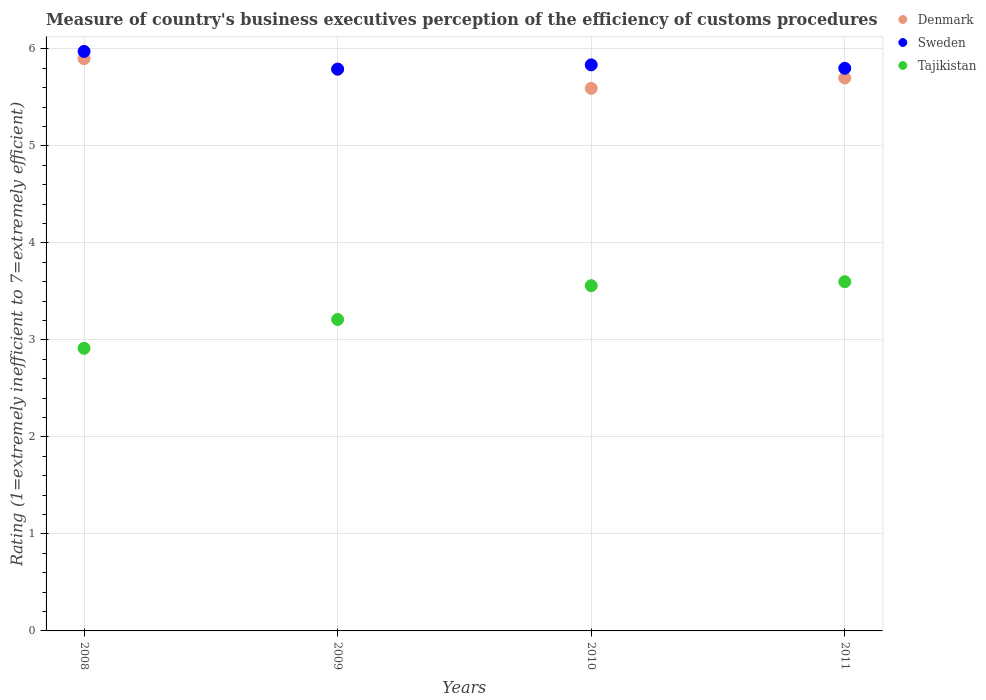Is the number of dotlines equal to the number of legend labels?
Offer a very short reply. Yes. What is the rating of the efficiency of customs procedure in Denmark in 2010?
Your answer should be compact. 5.59. Across all years, what is the maximum rating of the efficiency of customs procedure in Sweden?
Provide a short and direct response. 5.97. Across all years, what is the minimum rating of the efficiency of customs procedure in Denmark?
Keep it short and to the point. 5.59. What is the total rating of the efficiency of customs procedure in Denmark in the graph?
Make the answer very short. 22.98. What is the difference between the rating of the efficiency of customs procedure in Sweden in 2009 and that in 2011?
Make the answer very short. -0.01. What is the difference between the rating of the efficiency of customs procedure in Denmark in 2011 and the rating of the efficiency of customs procedure in Sweden in 2009?
Ensure brevity in your answer.  -0.09. What is the average rating of the efficiency of customs procedure in Denmark per year?
Your answer should be very brief. 5.75. In the year 2008, what is the difference between the rating of the efficiency of customs procedure in Tajikistan and rating of the efficiency of customs procedure in Sweden?
Your answer should be very brief. -3.06. In how many years, is the rating of the efficiency of customs procedure in Sweden greater than 4?
Give a very brief answer. 4. What is the ratio of the rating of the efficiency of customs procedure in Sweden in 2008 to that in 2011?
Offer a terse response. 1.03. Is the difference between the rating of the efficiency of customs procedure in Tajikistan in 2008 and 2009 greater than the difference between the rating of the efficiency of customs procedure in Sweden in 2008 and 2009?
Offer a very short reply. No. What is the difference between the highest and the second highest rating of the efficiency of customs procedure in Denmark?
Provide a succinct answer. 0.11. What is the difference between the highest and the lowest rating of the efficiency of customs procedure in Tajikistan?
Provide a short and direct response. 0.69. In how many years, is the rating of the efficiency of customs procedure in Sweden greater than the average rating of the efficiency of customs procedure in Sweden taken over all years?
Your response must be concise. 1. Is the sum of the rating of the efficiency of customs procedure in Sweden in 2008 and 2011 greater than the maximum rating of the efficiency of customs procedure in Tajikistan across all years?
Your answer should be compact. Yes. Is the rating of the efficiency of customs procedure in Tajikistan strictly less than the rating of the efficiency of customs procedure in Sweden over the years?
Give a very brief answer. Yes. How many dotlines are there?
Provide a short and direct response. 3. How many years are there in the graph?
Provide a short and direct response. 4. What is the difference between two consecutive major ticks on the Y-axis?
Ensure brevity in your answer.  1. Where does the legend appear in the graph?
Keep it short and to the point. Top right. What is the title of the graph?
Offer a very short reply. Measure of country's business executives perception of the efficiency of customs procedures. What is the label or title of the X-axis?
Your answer should be compact. Years. What is the label or title of the Y-axis?
Provide a short and direct response. Rating (1=extremely inefficient to 7=extremely efficient). What is the Rating (1=extremely inefficient to 7=extremely efficient) of Denmark in 2008?
Provide a short and direct response. 5.9. What is the Rating (1=extremely inefficient to 7=extremely efficient) in Sweden in 2008?
Your answer should be very brief. 5.97. What is the Rating (1=extremely inefficient to 7=extremely efficient) in Tajikistan in 2008?
Your answer should be compact. 2.91. What is the Rating (1=extremely inefficient to 7=extremely efficient) of Denmark in 2009?
Ensure brevity in your answer.  5.79. What is the Rating (1=extremely inefficient to 7=extremely efficient) in Sweden in 2009?
Provide a short and direct response. 5.79. What is the Rating (1=extremely inefficient to 7=extremely efficient) of Tajikistan in 2009?
Ensure brevity in your answer.  3.21. What is the Rating (1=extremely inefficient to 7=extremely efficient) in Denmark in 2010?
Your answer should be very brief. 5.59. What is the Rating (1=extremely inefficient to 7=extremely efficient) in Sweden in 2010?
Keep it short and to the point. 5.84. What is the Rating (1=extremely inefficient to 7=extremely efficient) in Tajikistan in 2010?
Keep it short and to the point. 3.56. What is the Rating (1=extremely inefficient to 7=extremely efficient) in Denmark in 2011?
Offer a terse response. 5.7. What is the Rating (1=extremely inefficient to 7=extremely efficient) of Sweden in 2011?
Your response must be concise. 5.8. Across all years, what is the maximum Rating (1=extremely inefficient to 7=extremely efficient) of Denmark?
Ensure brevity in your answer.  5.9. Across all years, what is the maximum Rating (1=extremely inefficient to 7=extremely efficient) of Sweden?
Your answer should be very brief. 5.97. Across all years, what is the maximum Rating (1=extremely inefficient to 7=extremely efficient) of Tajikistan?
Make the answer very short. 3.6. Across all years, what is the minimum Rating (1=extremely inefficient to 7=extremely efficient) in Denmark?
Ensure brevity in your answer.  5.59. Across all years, what is the minimum Rating (1=extremely inefficient to 7=extremely efficient) in Sweden?
Offer a terse response. 5.79. Across all years, what is the minimum Rating (1=extremely inefficient to 7=extremely efficient) of Tajikistan?
Offer a very short reply. 2.91. What is the total Rating (1=extremely inefficient to 7=extremely efficient) in Denmark in the graph?
Ensure brevity in your answer.  22.98. What is the total Rating (1=extremely inefficient to 7=extremely efficient) of Sweden in the graph?
Keep it short and to the point. 23.4. What is the total Rating (1=extremely inefficient to 7=extremely efficient) in Tajikistan in the graph?
Keep it short and to the point. 13.28. What is the difference between the Rating (1=extremely inefficient to 7=extremely efficient) of Denmark in 2008 and that in 2009?
Your answer should be very brief. 0.11. What is the difference between the Rating (1=extremely inefficient to 7=extremely efficient) in Sweden in 2008 and that in 2009?
Your answer should be compact. 0.18. What is the difference between the Rating (1=extremely inefficient to 7=extremely efficient) of Tajikistan in 2008 and that in 2009?
Make the answer very short. -0.3. What is the difference between the Rating (1=extremely inefficient to 7=extremely efficient) in Denmark in 2008 and that in 2010?
Keep it short and to the point. 0.31. What is the difference between the Rating (1=extremely inefficient to 7=extremely efficient) of Sweden in 2008 and that in 2010?
Give a very brief answer. 0.14. What is the difference between the Rating (1=extremely inefficient to 7=extremely efficient) of Tajikistan in 2008 and that in 2010?
Offer a terse response. -0.65. What is the difference between the Rating (1=extremely inefficient to 7=extremely efficient) of Denmark in 2008 and that in 2011?
Your response must be concise. 0.2. What is the difference between the Rating (1=extremely inefficient to 7=extremely efficient) of Sweden in 2008 and that in 2011?
Provide a short and direct response. 0.17. What is the difference between the Rating (1=extremely inefficient to 7=extremely efficient) of Tajikistan in 2008 and that in 2011?
Ensure brevity in your answer.  -0.69. What is the difference between the Rating (1=extremely inefficient to 7=extremely efficient) of Denmark in 2009 and that in 2010?
Keep it short and to the point. 0.2. What is the difference between the Rating (1=extremely inefficient to 7=extremely efficient) of Sweden in 2009 and that in 2010?
Your response must be concise. -0.04. What is the difference between the Rating (1=extremely inefficient to 7=extremely efficient) of Tajikistan in 2009 and that in 2010?
Give a very brief answer. -0.35. What is the difference between the Rating (1=extremely inefficient to 7=extremely efficient) in Denmark in 2009 and that in 2011?
Your answer should be very brief. 0.09. What is the difference between the Rating (1=extremely inefficient to 7=extremely efficient) of Sweden in 2009 and that in 2011?
Your answer should be compact. -0.01. What is the difference between the Rating (1=extremely inefficient to 7=extremely efficient) of Tajikistan in 2009 and that in 2011?
Your answer should be compact. -0.39. What is the difference between the Rating (1=extremely inefficient to 7=extremely efficient) in Denmark in 2010 and that in 2011?
Provide a short and direct response. -0.11. What is the difference between the Rating (1=extremely inefficient to 7=extremely efficient) in Sweden in 2010 and that in 2011?
Keep it short and to the point. 0.04. What is the difference between the Rating (1=extremely inefficient to 7=extremely efficient) in Tajikistan in 2010 and that in 2011?
Keep it short and to the point. -0.04. What is the difference between the Rating (1=extremely inefficient to 7=extremely efficient) in Denmark in 2008 and the Rating (1=extremely inefficient to 7=extremely efficient) in Sweden in 2009?
Your answer should be very brief. 0.11. What is the difference between the Rating (1=extremely inefficient to 7=extremely efficient) of Denmark in 2008 and the Rating (1=extremely inefficient to 7=extremely efficient) of Tajikistan in 2009?
Provide a short and direct response. 2.69. What is the difference between the Rating (1=extremely inefficient to 7=extremely efficient) of Sweden in 2008 and the Rating (1=extremely inefficient to 7=extremely efficient) of Tajikistan in 2009?
Offer a very short reply. 2.76. What is the difference between the Rating (1=extremely inefficient to 7=extremely efficient) of Denmark in 2008 and the Rating (1=extremely inefficient to 7=extremely efficient) of Sweden in 2010?
Give a very brief answer. 0.06. What is the difference between the Rating (1=extremely inefficient to 7=extremely efficient) in Denmark in 2008 and the Rating (1=extremely inefficient to 7=extremely efficient) in Tajikistan in 2010?
Offer a very short reply. 2.34. What is the difference between the Rating (1=extremely inefficient to 7=extremely efficient) of Sweden in 2008 and the Rating (1=extremely inefficient to 7=extremely efficient) of Tajikistan in 2010?
Your answer should be very brief. 2.41. What is the difference between the Rating (1=extremely inefficient to 7=extremely efficient) of Denmark in 2008 and the Rating (1=extremely inefficient to 7=extremely efficient) of Sweden in 2011?
Keep it short and to the point. 0.1. What is the difference between the Rating (1=extremely inefficient to 7=extremely efficient) of Denmark in 2008 and the Rating (1=extremely inefficient to 7=extremely efficient) of Tajikistan in 2011?
Your answer should be compact. 2.3. What is the difference between the Rating (1=extremely inefficient to 7=extremely efficient) in Sweden in 2008 and the Rating (1=extremely inefficient to 7=extremely efficient) in Tajikistan in 2011?
Offer a terse response. 2.37. What is the difference between the Rating (1=extremely inefficient to 7=extremely efficient) of Denmark in 2009 and the Rating (1=extremely inefficient to 7=extremely efficient) of Sweden in 2010?
Your answer should be compact. -0.05. What is the difference between the Rating (1=extremely inefficient to 7=extremely efficient) in Denmark in 2009 and the Rating (1=extremely inefficient to 7=extremely efficient) in Tajikistan in 2010?
Ensure brevity in your answer.  2.23. What is the difference between the Rating (1=extremely inefficient to 7=extremely efficient) in Sweden in 2009 and the Rating (1=extremely inefficient to 7=extremely efficient) in Tajikistan in 2010?
Offer a very short reply. 2.23. What is the difference between the Rating (1=extremely inefficient to 7=extremely efficient) of Denmark in 2009 and the Rating (1=extremely inefficient to 7=extremely efficient) of Sweden in 2011?
Keep it short and to the point. -0.01. What is the difference between the Rating (1=extremely inefficient to 7=extremely efficient) of Denmark in 2009 and the Rating (1=extremely inefficient to 7=extremely efficient) of Tajikistan in 2011?
Ensure brevity in your answer.  2.19. What is the difference between the Rating (1=extremely inefficient to 7=extremely efficient) of Sweden in 2009 and the Rating (1=extremely inefficient to 7=extremely efficient) of Tajikistan in 2011?
Your response must be concise. 2.19. What is the difference between the Rating (1=extremely inefficient to 7=extremely efficient) in Denmark in 2010 and the Rating (1=extremely inefficient to 7=extremely efficient) in Sweden in 2011?
Ensure brevity in your answer.  -0.21. What is the difference between the Rating (1=extremely inefficient to 7=extremely efficient) in Denmark in 2010 and the Rating (1=extremely inefficient to 7=extremely efficient) in Tajikistan in 2011?
Provide a short and direct response. 1.99. What is the difference between the Rating (1=extremely inefficient to 7=extremely efficient) in Sweden in 2010 and the Rating (1=extremely inefficient to 7=extremely efficient) in Tajikistan in 2011?
Offer a very short reply. 2.24. What is the average Rating (1=extremely inefficient to 7=extremely efficient) of Denmark per year?
Provide a succinct answer. 5.75. What is the average Rating (1=extremely inefficient to 7=extremely efficient) of Sweden per year?
Give a very brief answer. 5.85. What is the average Rating (1=extremely inefficient to 7=extremely efficient) in Tajikistan per year?
Your response must be concise. 3.32. In the year 2008, what is the difference between the Rating (1=extremely inefficient to 7=extremely efficient) in Denmark and Rating (1=extremely inefficient to 7=extremely efficient) in Sweden?
Keep it short and to the point. -0.07. In the year 2008, what is the difference between the Rating (1=extremely inefficient to 7=extremely efficient) in Denmark and Rating (1=extremely inefficient to 7=extremely efficient) in Tajikistan?
Offer a very short reply. 2.99. In the year 2008, what is the difference between the Rating (1=extremely inefficient to 7=extremely efficient) in Sweden and Rating (1=extremely inefficient to 7=extremely efficient) in Tajikistan?
Offer a terse response. 3.06. In the year 2009, what is the difference between the Rating (1=extremely inefficient to 7=extremely efficient) of Denmark and Rating (1=extremely inefficient to 7=extremely efficient) of Sweden?
Offer a terse response. -0. In the year 2009, what is the difference between the Rating (1=extremely inefficient to 7=extremely efficient) of Denmark and Rating (1=extremely inefficient to 7=extremely efficient) of Tajikistan?
Your answer should be very brief. 2.58. In the year 2009, what is the difference between the Rating (1=extremely inefficient to 7=extremely efficient) in Sweden and Rating (1=extremely inefficient to 7=extremely efficient) in Tajikistan?
Provide a short and direct response. 2.58. In the year 2010, what is the difference between the Rating (1=extremely inefficient to 7=extremely efficient) of Denmark and Rating (1=extremely inefficient to 7=extremely efficient) of Sweden?
Make the answer very short. -0.24. In the year 2010, what is the difference between the Rating (1=extremely inefficient to 7=extremely efficient) in Denmark and Rating (1=extremely inefficient to 7=extremely efficient) in Tajikistan?
Your response must be concise. 2.03. In the year 2010, what is the difference between the Rating (1=extremely inefficient to 7=extremely efficient) of Sweden and Rating (1=extremely inefficient to 7=extremely efficient) of Tajikistan?
Provide a succinct answer. 2.28. In the year 2011, what is the difference between the Rating (1=extremely inefficient to 7=extremely efficient) of Denmark and Rating (1=extremely inefficient to 7=extremely efficient) of Sweden?
Offer a terse response. -0.1. What is the ratio of the Rating (1=extremely inefficient to 7=extremely efficient) in Sweden in 2008 to that in 2009?
Offer a terse response. 1.03. What is the ratio of the Rating (1=extremely inefficient to 7=extremely efficient) in Tajikistan in 2008 to that in 2009?
Your answer should be compact. 0.91. What is the ratio of the Rating (1=extremely inefficient to 7=extremely efficient) in Denmark in 2008 to that in 2010?
Your answer should be very brief. 1.05. What is the ratio of the Rating (1=extremely inefficient to 7=extremely efficient) of Sweden in 2008 to that in 2010?
Offer a very short reply. 1.02. What is the ratio of the Rating (1=extremely inefficient to 7=extremely efficient) of Tajikistan in 2008 to that in 2010?
Give a very brief answer. 0.82. What is the ratio of the Rating (1=extremely inefficient to 7=extremely efficient) of Denmark in 2008 to that in 2011?
Provide a short and direct response. 1.03. What is the ratio of the Rating (1=extremely inefficient to 7=extremely efficient) in Tajikistan in 2008 to that in 2011?
Your answer should be compact. 0.81. What is the ratio of the Rating (1=extremely inefficient to 7=extremely efficient) in Denmark in 2009 to that in 2010?
Your response must be concise. 1.04. What is the ratio of the Rating (1=extremely inefficient to 7=extremely efficient) in Sweden in 2009 to that in 2010?
Give a very brief answer. 0.99. What is the ratio of the Rating (1=extremely inefficient to 7=extremely efficient) in Tajikistan in 2009 to that in 2010?
Your answer should be compact. 0.9. What is the ratio of the Rating (1=extremely inefficient to 7=extremely efficient) in Denmark in 2009 to that in 2011?
Your answer should be very brief. 1.02. What is the ratio of the Rating (1=extremely inefficient to 7=extremely efficient) in Tajikistan in 2009 to that in 2011?
Give a very brief answer. 0.89. What is the ratio of the Rating (1=extremely inefficient to 7=extremely efficient) of Denmark in 2010 to that in 2011?
Provide a succinct answer. 0.98. What is the ratio of the Rating (1=extremely inefficient to 7=extremely efficient) in Tajikistan in 2010 to that in 2011?
Your response must be concise. 0.99. What is the difference between the highest and the second highest Rating (1=extremely inefficient to 7=extremely efficient) in Denmark?
Provide a short and direct response. 0.11. What is the difference between the highest and the second highest Rating (1=extremely inefficient to 7=extremely efficient) in Sweden?
Offer a very short reply. 0.14. What is the difference between the highest and the second highest Rating (1=extremely inefficient to 7=extremely efficient) in Tajikistan?
Offer a very short reply. 0.04. What is the difference between the highest and the lowest Rating (1=extremely inefficient to 7=extremely efficient) of Denmark?
Your answer should be very brief. 0.31. What is the difference between the highest and the lowest Rating (1=extremely inefficient to 7=extremely efficient) in Sweden?
Your response must be concise. 0.18. What is the difference between the highest and the lowest Rating (1=extremely inefficient to 7=extremely efficient) of Tajikistan?
Your answer should be compact. 0.69. 